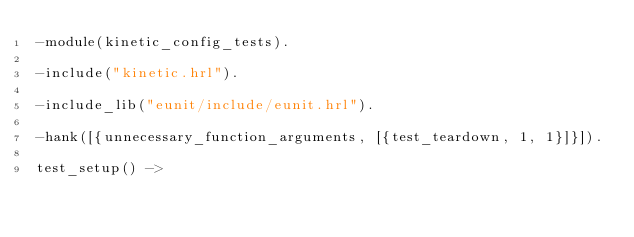Convert code to text. <code><loc_0><loc_0><loc_500><loc_500><_Erlang_>-module(kinetic_config_tests).

-include("kinetic.hrl").

-include_lib("eunit/include/eunit.hrl").

-hank([{unnecessary_function_arguments, [{test_teardown, 1, 1}]}]).

test_setup() -></code> 